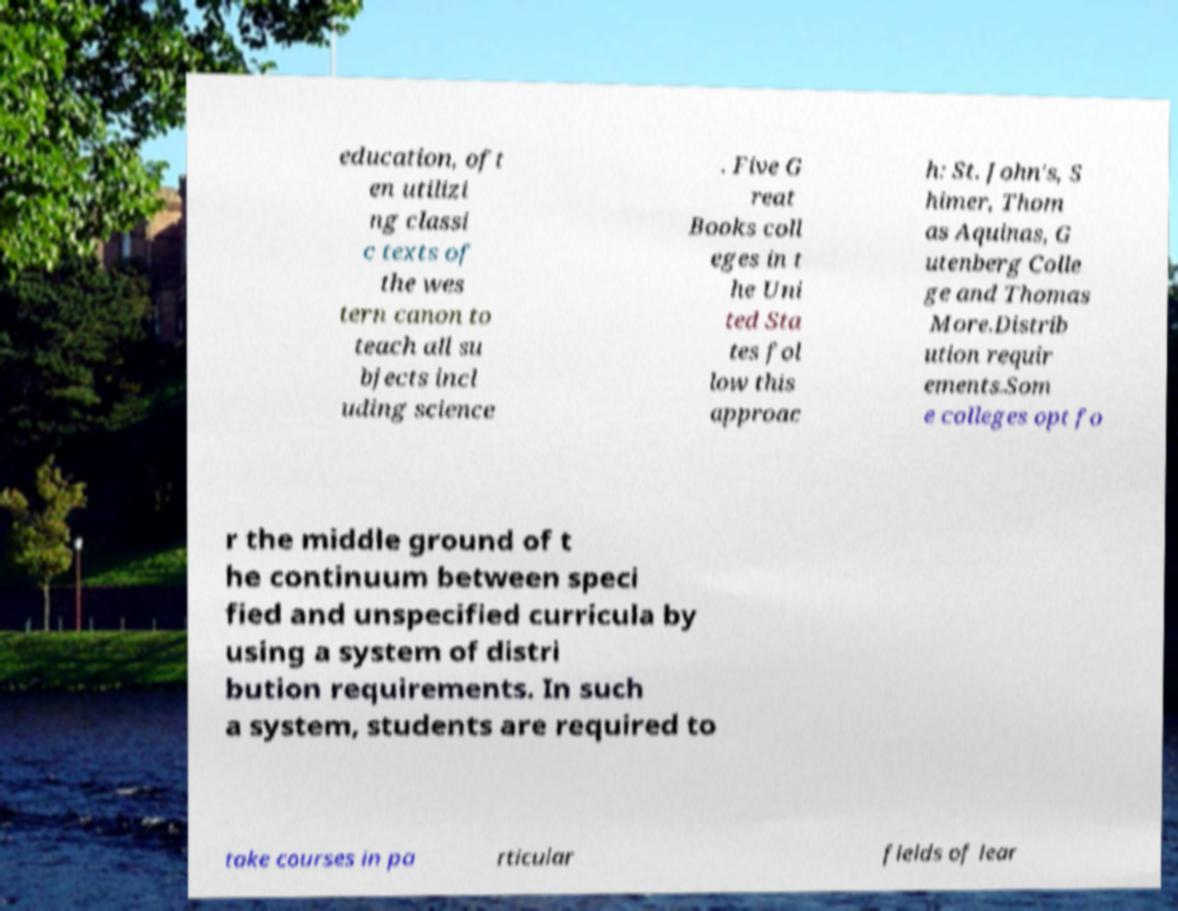I need the written content from this picture converted into text. Can you do that? education, oft en utilizi ng classi c texts of the wes tern canon to teach all su bjects incl uding science . Five G reat Books coll eges in t he Uni ted Sta tes fol low this approac h: St. John's, S himer, Thom as Aquinas, G utenberg Colle ge and Thomas More.Distrib ution requir ements.Som e colleges opt fo r the middle ground of t he continuum between speci fied and unspecified curricula by using a system of distri bution requirements. In such a system, students are required to take courses in pa rticular fields of lear 